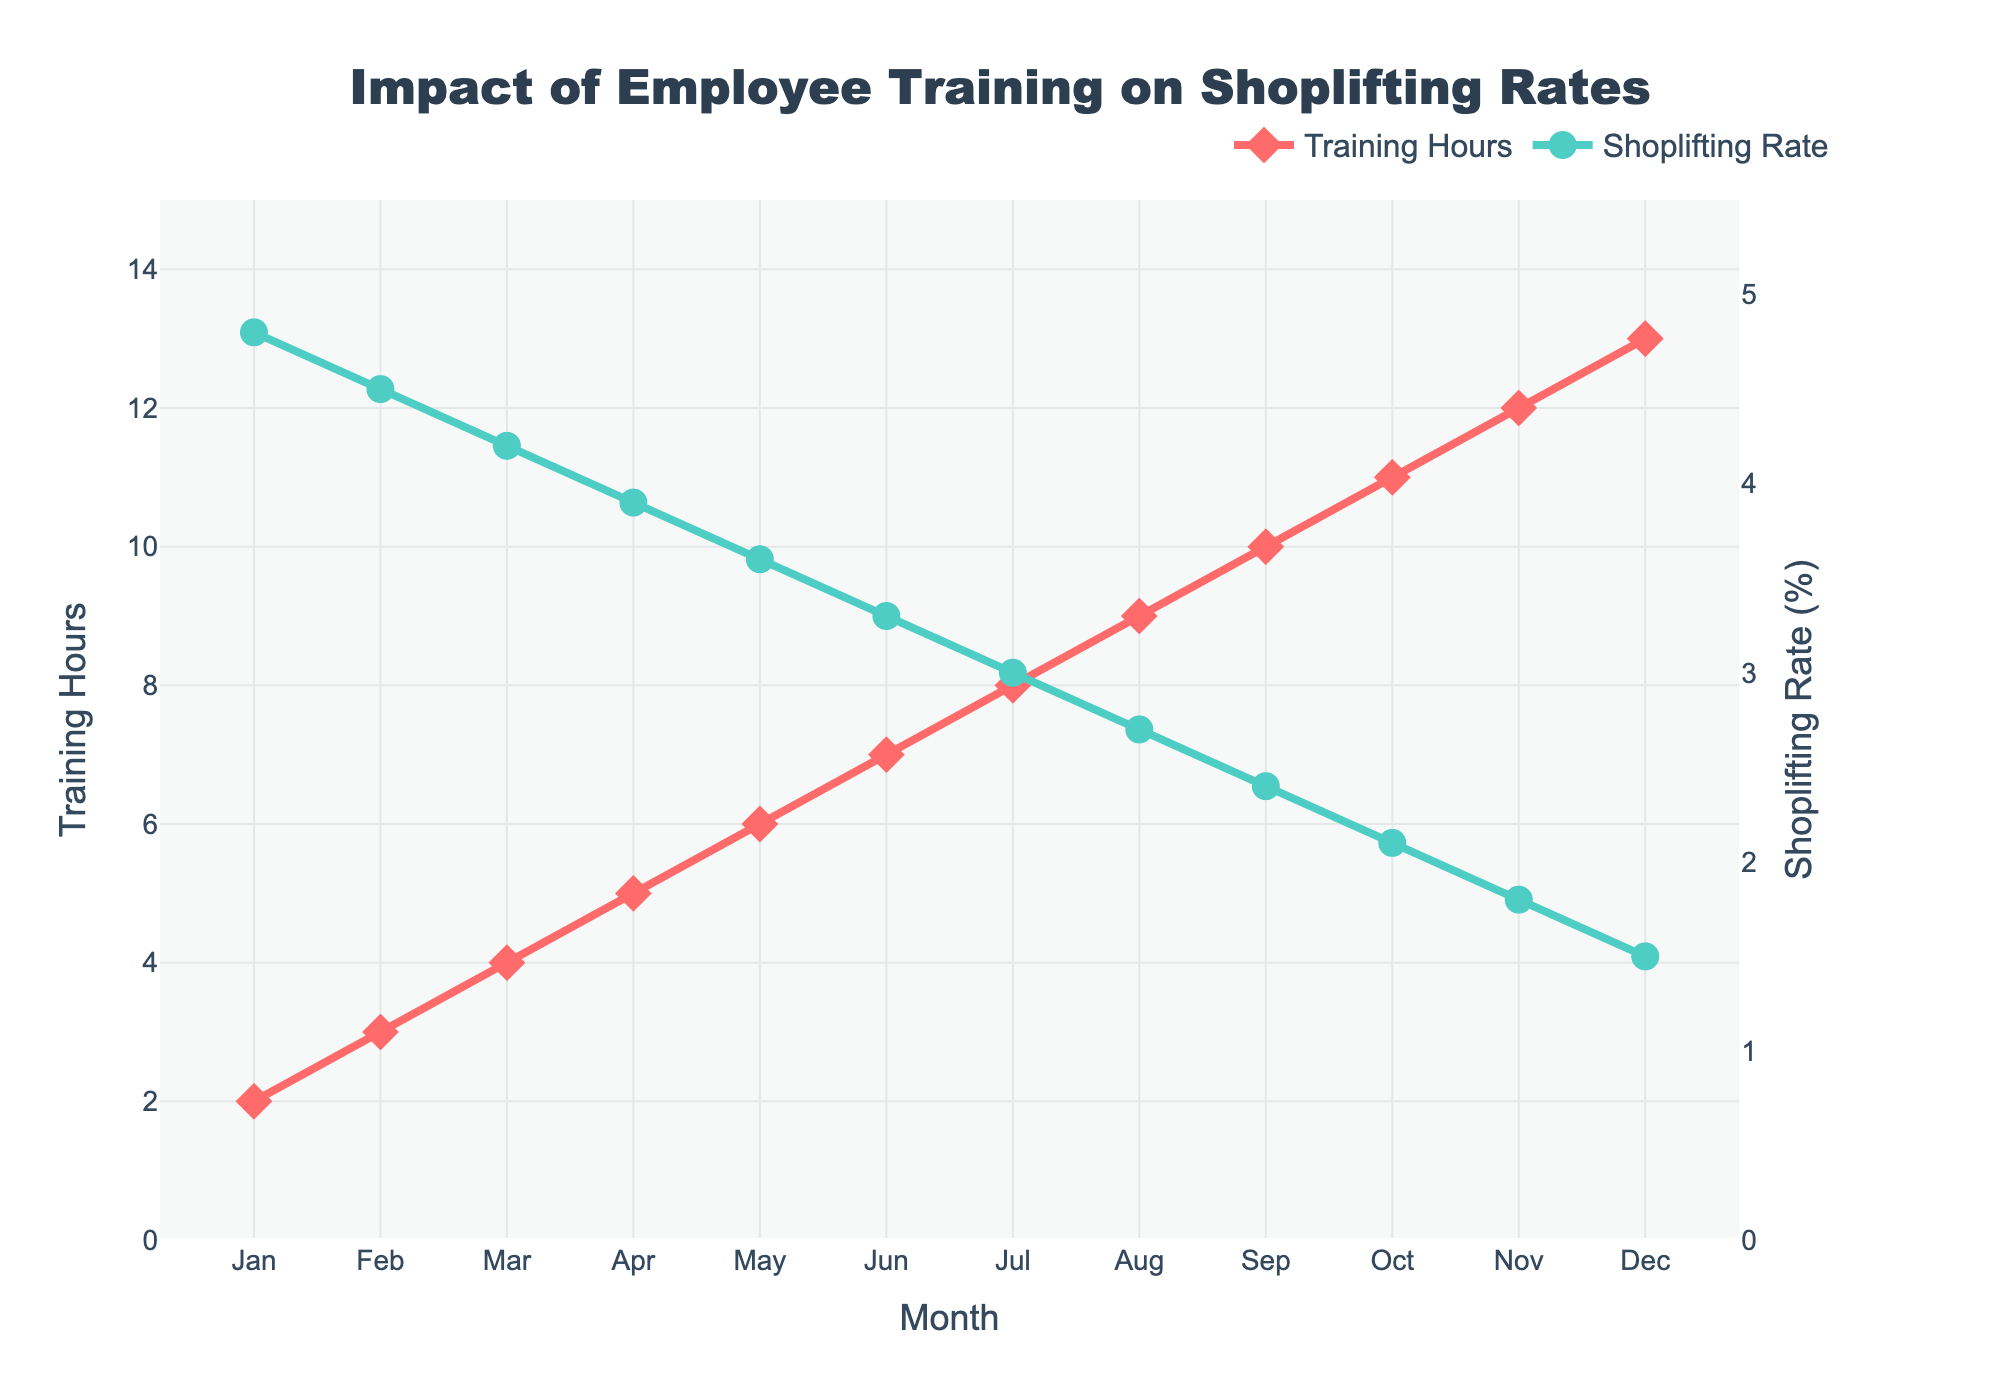What is the relationship between training hours and shoplifting rate over the months? The figure shows that as the number of training hours increases, the shoplifting rate decreases. For instance, in January when training hours were 2, the shoplifting rate was 4.8%. By December, training hours increased to 13 and the shoplifting rate decreased to 1.5%. This indicates a negative correlation between training hours and shoplifting rate.
Answer: As training hours increase, shoplifting rate decreases Which month has the highest shoplifting rate and what are the corresponding training hours? According to the figure, the highest shoplifting rate occurs in January with a rate of 4.8%. At this time, the corresponding training hours are 2 hours.
Answer: January, 4.8% shoplifting rate, 2 training hours What is the difference in training hours between February and November? In February, the training hours are 3, while in November they are 12. The difference is calculated as 12 - 3.
Answer: 9 hours Which month shows the largest decrease in shoplifting rate from the previous month? By examining the shoplifting rate for each month, the largest decrease is observed from January to February. In January, the shoplifting rate was 4.8% and in February it drops to 4.5%, corresponding to a decrease of 0.3%.
Answer: February What is the average shoplifting rate over the first half of the year (January to June)? The shoplifting rates from January to June are 4.8, 4.5, 4.2, 3.9, 3.6, and 3.3 respectively. Summing these values gives 24.3. Dividing by the number of months (6) gives the average shoplifting rate: 24.3 / 6.
Answer: 4.05% Which trend line is represented by red? The trend line represented by red (line with diamond markers) corresponds to Training Hours as indicated in the legend.
Answer: Training Hours In what month does the shoplifting rate drop below 3%? As per the visual trend, the shoplifting rate first drops below 3% in July.
Answer: July How many months show a shoplifting rate equal to or below 2%? By examining the figure, months with a shoplifting rate equal to or below 2% are October, November, and December. Hence, there are 3 months.
Answer: 3 months What is the total increase in training hours from January to December? Training hours in January are 2 and in December are 13. The total increase is calculated by subtracting the January value from the December value: 13 - 2.
Answer: 11 hours What visual element differentiates the shoplifting rate line from the training hours line? The shoplifting rate line is represented with green color and circle markers, while the training hours line is red with diamond markers; this visually distinguishes the two trend lines.
Answer: Color and marker shape 